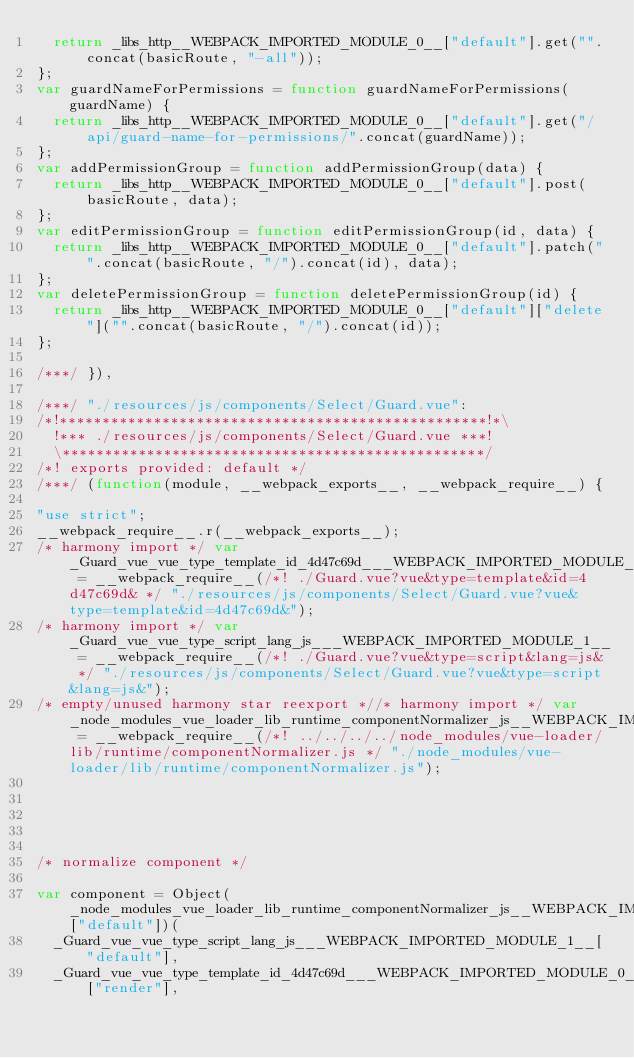<code> <loc_0><loc_0><loc_500><loc_500><_JavaScript_>  return _libs_http__WEBPACK_IMPORTED_MODULE_0__["default"].get("".concat(basicRoute, "-all"));
};
var guardNameForPermissions = function guardNameForPermissions(guardName) {
  return _libs_http__WEBPACK_IMPORTED_MODULE_0__["default"].get("/api/guard-name-for-permissions/".concat(guardName));
};
var addPermissionGroup = function addPermissionGroup(data) {
  return _libs_http__WEBPACK_IMPORTED_MODULE_0__["default"].post(basicRoute, data);
};
var editPermissionGroup = function editPermissionGroup(id, data) {
  return _libs_http__WEBPACK_IMPORTED_MODULE_0__["default"].patch("".concat(basicRoute, "/").concat(id), data);
};
var deletePermissionGroup = function deletePermissionGroup(id) {
  return _libs_http__WEBPACK_IMPORTED_MODULE_0__["default"]["delete"]("".concat(basicRoute, "/").concat(id));
};

/***/ }),

/***/ "./resources/js/components/Select/Guard.vue":
/*!**************************************************!*\
  !*** ./resources/js/components/Select/Guard.vue ***!
  \**************************************************/
/*! exports provided: default */
/***/ (function(module, __webpack_exports__, __webpack_require__) {

"use strict";
__webpack_require__.r(__webpack_exports__);
/* harmony import */ var _Guard_vue_vue_type_template_id_4d47c69d___WEBPACK_IMPORTED_MODULE_0__ = __webpack_require__(/*! ./Guard.vue?vue&type=template&id=4d47c69d& */ "./resources/js/components/Select/Guard.vue?vue&type=template&id=4d47c69d&");
/* harmony import */ var _Guard_vue_vue_type_script_lang_js___WEBPACK_IMPORTED_MODULE_1__ = __webpack_require__(/*! ./Guard.vue?vue&type=script&lang=js& */ "./resources/js/components/Select/Guard.vue?vue&type=script&lang=js&");
/* empty/unused harmony star reexport *//* harmony import */ var _node_modules_vue_loader_lib_runtime_componentNormalizer_js__WEBPACK_IMPORTED_MODULE_2__ = __webpack_require__(/*! ../../../../node_modules/vue-loader/lib/runtime/componentNormalizer.js */ "./node_modules/vue-loader/lib/runtime/componentNormalizer.js");





/* normalize component */

var component = Object(_node_modules_vue_loader_lib_runtime_componentNormalizer_js__WEBPACK_IMPORTED_MODULE_2__["default"])(
  _Guard_vue_vue_type_script_lang_js___WEBPACK_IMPORTED_MODULE_1__["default"],
  _Guard_vue_vue_type_template_id_4d47c69d___WEBPACK_IMPORTED_MODULE_0__["render"],</code> 